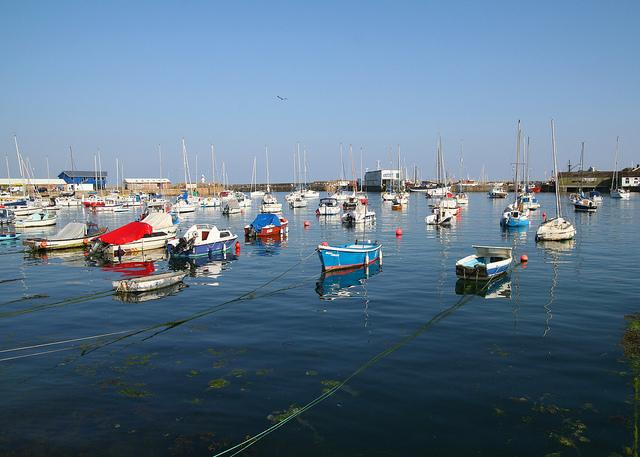These items that are moving can be referred to as being part of what? fleet 